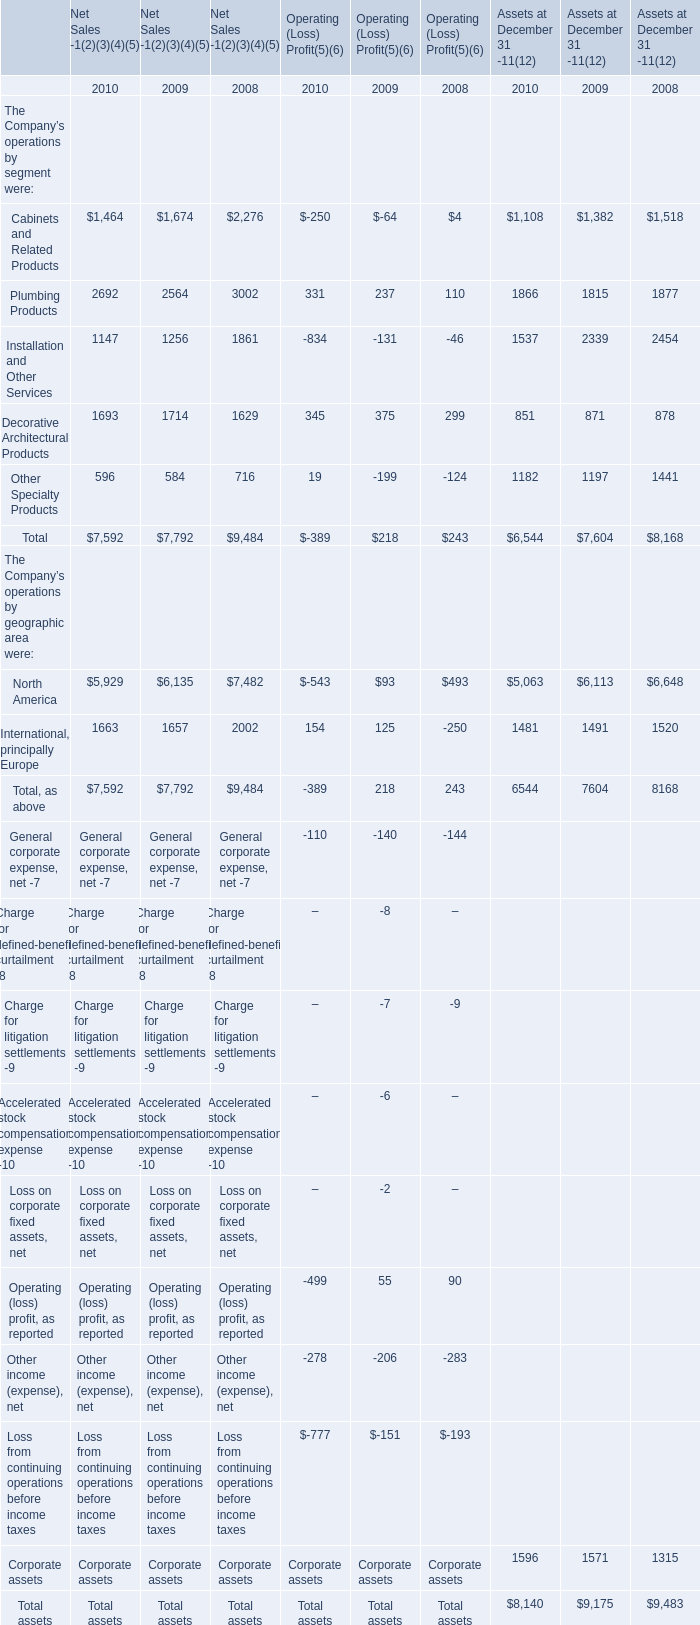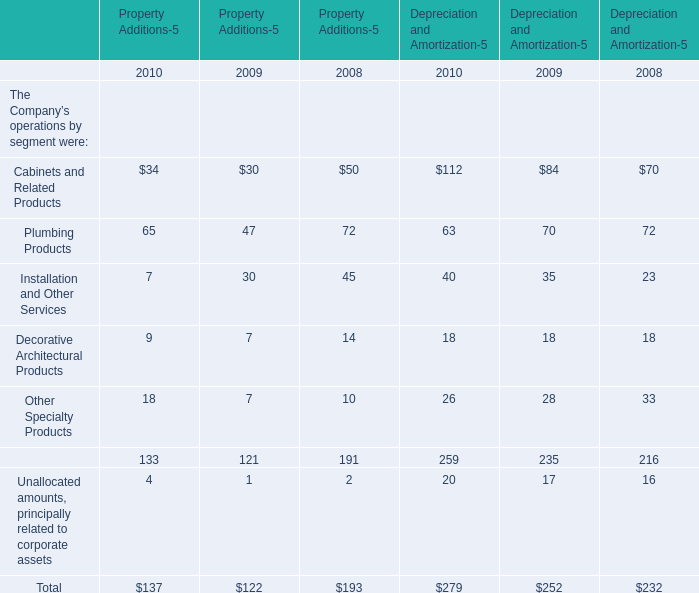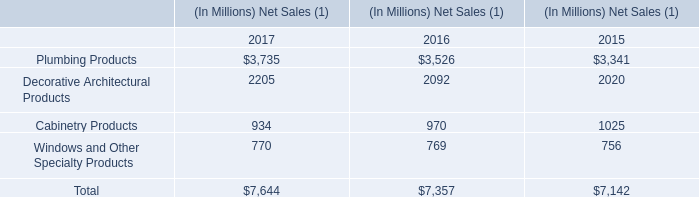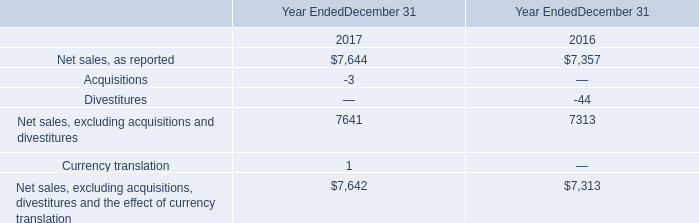What is the sum of the Depreciation and Amortization in terms of Plumbing Products in 2010? 
Answer: 63. 